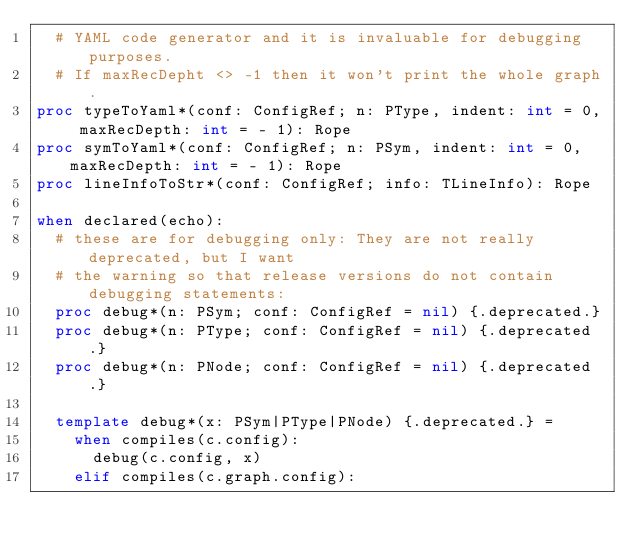<code> <loc_0><loc_0><loc_500><loc_500><_Nim_>  # YAML code generator and it is invaluable for debugging purposes.
  # If maxRecDepht <> -1 then it won't print the whole graph.
proc typeToYaml*(conf: ConfigRef; n: PType, indent: int = 0, maxRecDepth: int = - 1): Rope
proc symToYaml*(conf: ConfigRef; n: PSym, indent: int = 0, maxRecDepth: int = - 1): Rope
proc lineInfoToStr*(conf: ConfigRef; info: TLineInfo): Rope

when declared(echo):
  # these are for debugging only: They are not really deprecated, but I want
  # the warning so that release versions do not contain debugging statements:
  proc debug*(n: PSym; conf: ConfigRef = nil) {.deprecated.}
  proc debug*(n: PType; conf: ConfigRef = nil) {.deprecated.}
  proc debug*(n: PNode; conf: ConfigRef = nil) {.deprecated.}

  template debug*(x: PSym|PType|PNode) {.deprecated.} =
    when compiles(c.config):
      debug(c.config, x)
    elif compiles(c.graph.config):</code> 